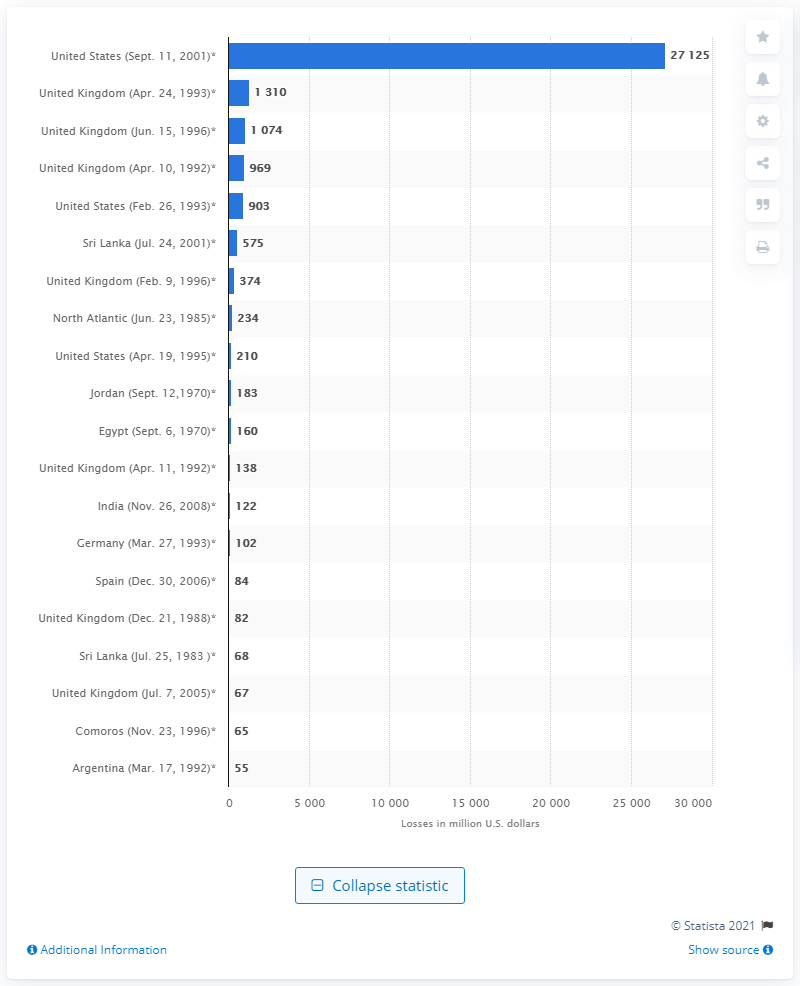Specify some key components in this picture. The bombing of Israel's embassy in Buenos Aires resulted in significant insured property losses of approximately $55. The total insured property losses from the terrorist attacks in New York, Washington, and Pennsylvania were approximately $271.25 billion. 